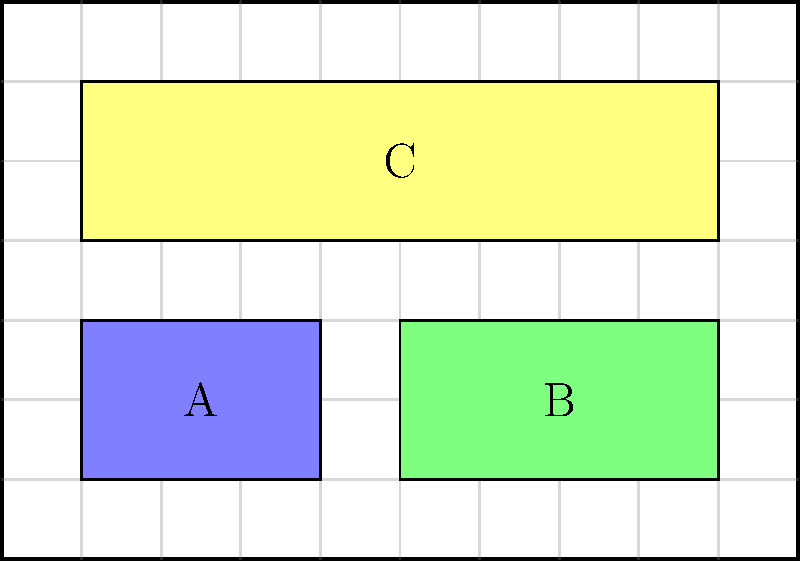In the magazine spread layout shown above, which visual elements are in congruence with each other, and how can you improve the overall alignment to create a more cohesive design? To analyze the congruence and alignment of visual elements in this magazine spread layout, let's follow these steps:

1. Identify the elements:
   A: Blue rectangle (left)
   B: Green rectangle (right)
   C: Yellow rectangle (spanning the width)

2. Analyze vertical alignment:
   - Elements A and B are aligned at the top and bottom
   - Element C is not aligned with A and B vertically

3. Analyze horizontal alignment:
   - Elements A and B are not aligned horizontally
   - Element C spans the width, aligning with both A and B on their outer edges

4. Assess congruence:
   - A and B are congruent in height but not width
   - C is not congruent with A or B

5. Improve alignment and congruence:
   a) Vertically align C with A and B by moving it down to the same baseline
   b) Make A and B the same width to achieve full congruence
   c) Adjust the width of C to match the combined width of A and B
   d) Ensure consistent spacing between all elements

By implementing these improvements, the layout will have better alignment and congruence, creating a more cohesive and visually appealing design that's easier for readers to navigate.
Answer: A and B are partially congruent (same height). Improve by aligning C vertically, equalizing A and B's widths, and adjusting C's width to match A+B. 